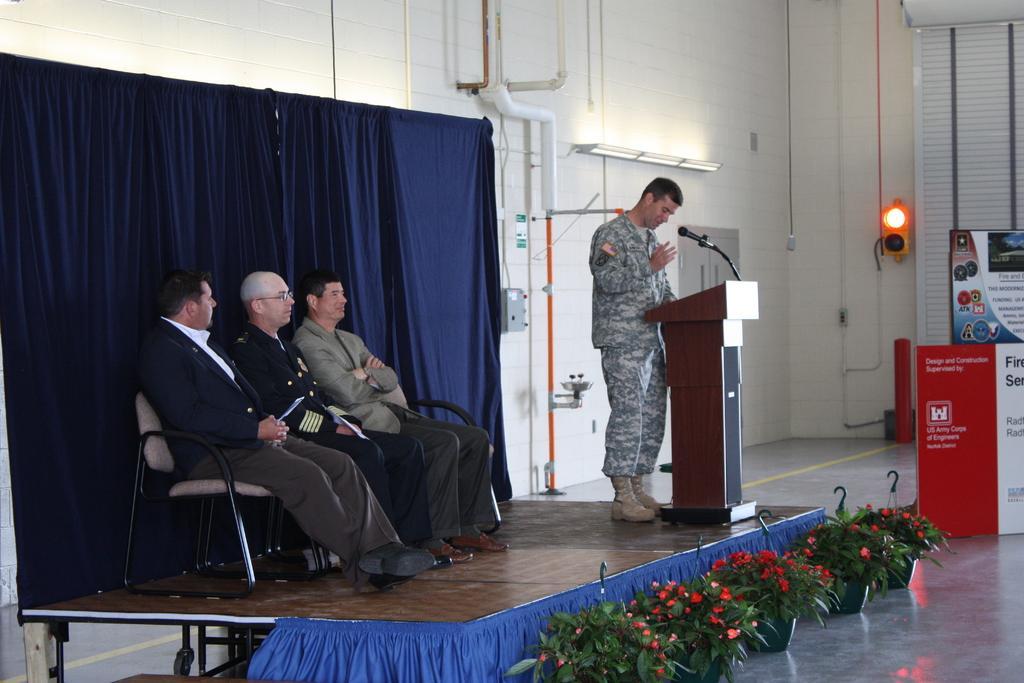Could you give a brief overview of what you see in this image? In this image i can see three man sitting on a chair , a man at the right standing in front of the podium and there is a micro phone at the back ground i can see a wall an a pole. 